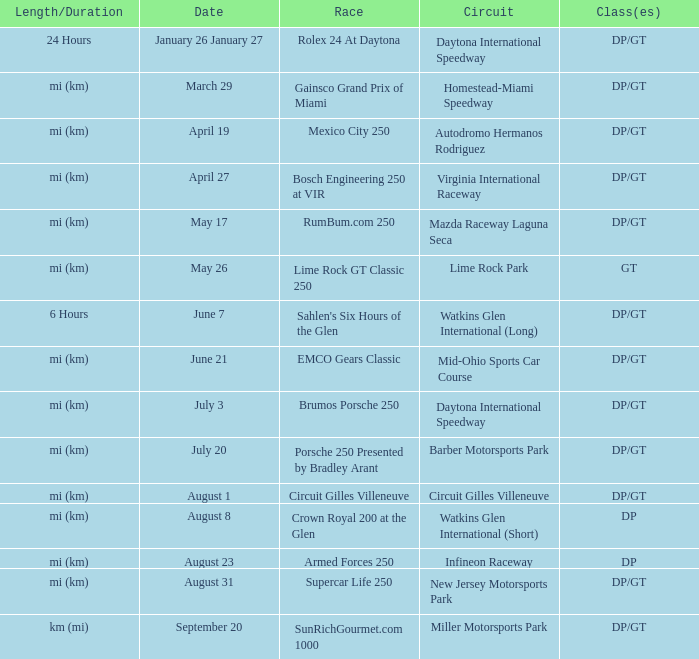What was the date of the race that lasted 6 hours? June 7. 